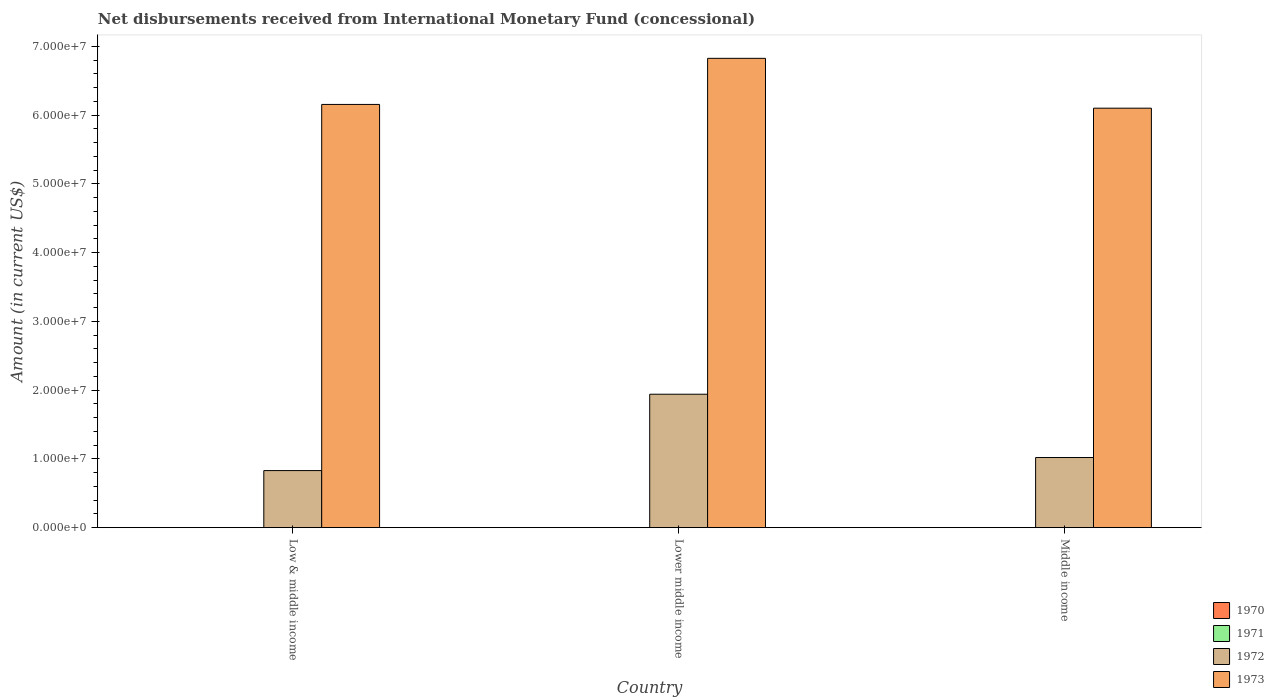How many different coloured bars are there?
Your answer should be very brief. 2. Are the number of bars per tick equal to the number of legend labels?
Ensure brevity in your answer.  No. How many bars are there on the 2nd tick from the left?
Ensure brevity in your answer.  2. What is the label of the 3rd group of bars from the left?
Make the answer very short. Middle income. In how many cases, is the number of bars for a given country not equal to the number of legend labels?
Ensure brevity in your answer.  3. What is the amount of disbursements received from International Monetary Fund in 1971 in Low & middle income?
Keep it short and to the point. 0. Across all countries, what is the maximum amount of disbursements received from International Monetary Fund in 1973?
Provide a short and direct response. 6.83e+07. Across all countries, what is the minimum amount of disbursements received from International Monetary Fund in 1973?
Provide a succinct answer. 6.10e+07. In which country was the amount of disbursements received from International Monetary Fund in 1972 maximum?
Keep it short and to the point. Lower middle income. What is the total amount of disbursements received from International Monetary Fund in 1973 in the graph?
Ensure brevity in your answer.  1.91e+08. What is the difference between the amount of disbursements received from International Monetary Fund in 1973 in Lower middle income and that in Middle income?
Offer a very short reply. 7.25e+06. What is the difference between the amount of disbursements received from International Monetary Fund in 1973 in Middle income and the amount of disbursements received from International Monetary Fund in 1972 in Lower middle income?
Keep it short and to the point. 4.16e+07. What is the average amount of disbursements received from International Monetary Fund in 1971 per country?
Keep it short and to the point. 0. What is the difference between the amount of disbursements received from International Monetary Fund of/in 1973 and amount of disbursements received from International Monetary Fund of/in 1972 in Lower middle income?
Provide a succinct answer. 4.89e+07. In how many countries, is the amount of disbursements received from International Monetary Fund in 1970 greater than 56000000 US$?
Your response must be concise. 0. What is the ratio of the amount of disbursements received from International Monetary Fund in 1972 in Lower middle income to that in Middle income?
Give a very brief answer. 1.9. Is the amount of disbursements received from International Monetary Fund in 1973 in Low & middle income less than that in Middle income?
Your answer should be compact. No. Is the difference between the amount of disbursements received from International Monetary Fund in 1973 in Low & middle income and Middle income greater than the difference between the amount of disbursements received from International Monetary Fund in 1972 in Low & middle income and Middle income?
Ensure brevity in your answer.  Yes. What is the difference between the highest and the second highest amount of disbursements received from International Monetary Fund in 1973?
Make the answer very short. -7.25e+06. What is the difference between the highest and the lowest amount of disbursements received from International Monetary Fund in 1973?
Provide a succinct answer. 7.25e+06. Is the sum of the amount of disbursements received from International Monetary Fund in 1972 in Low & middle income and Lower middle income greater than the maximum amount of disbursements received from International Monetary Fund in 1970 across all countries?
Give a very brief answer. Yes. Is it the case that in every country, the sum of the amount of disbursements received from International Monetary Fund in 1972 and amount of disbursements received from International Monetary Fund in 1973 is greater than the sum of amount of disbursements received from International Monetary Fund in 1971 and amount of disbursements received from International Monetary Fund in 1970?
Give a very brief answer. Yes. How many bars are there?
Keep it short and to the point. 6. Are all the bars in the graph horizontal?
Offer a very short reply. No. How many countries are there in the graph?
Provide a short and direct response. 3. What is the difference between two consecutive major ticks on the Y-axis?
Your response must be concise. 1.00e+07. Are the values on the major ticks of Y-axis written in scientific E-notation?
Ensure brevity in your answer.  Yes. Does the graph contain grids?
Your answer should be compact. No. How many legend labels are there?
Offer a terse response. 4. How are the legend labels stacked?
Offer a terse response. Vertical. What is the title of the graph?
Ensure brevity in your answer.  Net disbursements received from International Monetary Fund (concessional). Does "1971" appear as one of the legend labels in the graph?
Offer a terse response. Yes. What is the label or title of the X-axis?
Offer a terse response. Country. What is the Amount (in current US$) of 1970 in Low & middle income?
Your answer should be very brief. 0. What is the Amount (in current US$) of 1972 in Low & middle income?
Provide a short and direct response. 8.30e+06. What is the Amount (in current US$) in 1973 in Low & middle income?
Provide a short and direct response. 6.16e+07. What is the Amount (in current US$) of 1970 in Lower middle income?
Provide a short and direct response. 0. What is the Amount (in current US$) of 1972 in Lower middle income?
Keep it short and to the point. 1.94e+07. What is the Amount (in current US$) of 1973 in Lower middle income?
Give a very brief answer. 6.83e+07. What is the Amount (in current US$) in 1970 in Middle income?
Ensure brevity in your answer.  0. What is the Amount (in current US$) of 1971 in Middle income?
Your response must be concise. 0. What is the Amount (in current US$) in 1972 in Middle income?
Keep it short and to the point. 1.02e+07. What is the Amount (in current US$) of 1973 in Middle income?
Keep it short and to the point. 6.10e+07. Across all countries, what is the maximum Amount (in current US$) in 1972?
Your response must be concise. 1.94e+07. Across all countries, what is the maximum Amount (in current US$) in 1973?
Provide a succinct answer. 6.83e+07. Across all countries, what is the minimum Amount (in current US$) in 1972?
Your answer should be very brief. 8.30e+06. Across all countries, what is the minimum Amount (in current US$) in 1973?
Give a very brief answer. 6.10e+07. What is the total Amount (in current US$) in 1971 in the graph?
Provide a short and direct response. 0. What is the total Amount (in current US$) of 1972 in the graph?
Offer a very short reply. 3.79e+07. What is the total Amount (in current US$) of 1973 in the graph?
Offer a very short reply. 1.91e+08. What is the difference between the Amount (in current US$) of 1972 in Low & middle income and that in Lower middle income?
Keep it short and to the point. -1.11e+07. What is the difference between the Amount (in current US$) in 1973 in Low & middle income and that in Lower middle income?
Make the answer very short. -6.70e+06. What is the difference between the Amount (in current US$) in 1972 in Low & middle income and that in Middle income?
Ensure brevity in your answer.  -1.90e+06. What is the difference between the Amount (in current US$) in 1973 in Low & middle income and that in Middle income?
Make the answer very short. 5.46e+05. What is the difference between the Amount (in current US$) of 1972 in Lower middle income and that in Middle income?
Offer a terse response. 9.21e+06. What is the difference between the Amount (in current US$) in 1973 in Lower middle income and that in Middle income?
Your response must be concise. 7.25e+06. What is the difference between the Amount (in current US$) of 1972 in Low & middle income and the Amount (in current US$) of 1973 in Lower middle income?
Your answer should be very brief. -6.00e+07. What is the difference between the Amount (in current US$) of 1972 in Low & middle income and the Amount (in current US$) of 1973 in Middle income?
Provide a succinct answer. -5.27e+07. What is the difference between the Amount (in current US$) in 1972 in Lower middle income and the Amount (in current US$) in 1973 in Middle income?
Your response must be concise. -4.16e+07. What is the average Amount (in current US$) in 1971 per country?
Offer a very short reply. 0. What is the average Amount (in current US$) in 1972 per country?
Ensure brevity in your answer.  1.26e+07. What is the average Amount (in current US$) of 1973 per country?
Provide a succinct answer. 6.36e+07. What is the difference between the Amount (in current US$) of 1972 and Amount (in current US$) of 1973 in Low & middle income?
Offer a very short reply. -5.33e+07. What is the difference between the Amount (in current US$) of 1972 and Amount (in current US$) of 1973 in Lower middle income?
Ensure brevity in your answer.  -4.89e+07. What is the difference between the Amount (in current US$) in 1972 and Amount (in current US$) in 1973 in Middle income?
Make the answer very short. -5.08e+07. What is the ratio of the Amount (in current US$) of 1972 in Low & middle income to that in Lower middle income?
Ensure brevity in your answer.  0.43. What is the ratio of the Amount (in current US$) in 1973 in Low & middle income to that in Lower middle income?
Keep it short and to the point. 0.9. What is the ratio of the Amount (in current US$) in 1972 in Low & middle income to that in Middle income?
Your answer should be very brief. 0.81. What is the ratio of the Amount (in current US$) in 1972 in Lower middle income to that in Middle income?
Ensure brevity in your answer.  1.9. What is the ratio of the Amount (in current US$) in 1973 in Lower middle income to that in Middle income?
Give a very brief answer. 1.12. What is the difference between the highest and the second highest Amount (in current US$) of 1972?
Your answer should be very brief. 9.21e+06. What is the difference between the highest and the second highest Amount (in current US$) of 1973?
Keep it short and to the point. 6.70e+06. What is the difference between the highest and the lowest Amount (in current US$) of 1972?
Offer a very short reply. 1.11e+07. What is the difference between the highest and the lowest Amount (in current US$) of 1973?
Offer a terse response. 7.25e+06. 